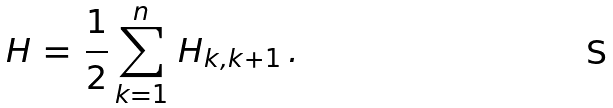Convert formula to latex. <formula><loc_0><loc_0><loc_500><loc_500>H \, = \, \frac { 1 } { 2 } \sum _ { k = 1 } ^ { n } \, H _ { k , k + 1 } \, .</formula> 